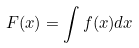Convert formula to latex. <formula><loc_0><loc_0><loc_500><loc_500>F ( x ) = \int f ( x ) d x</formula> 